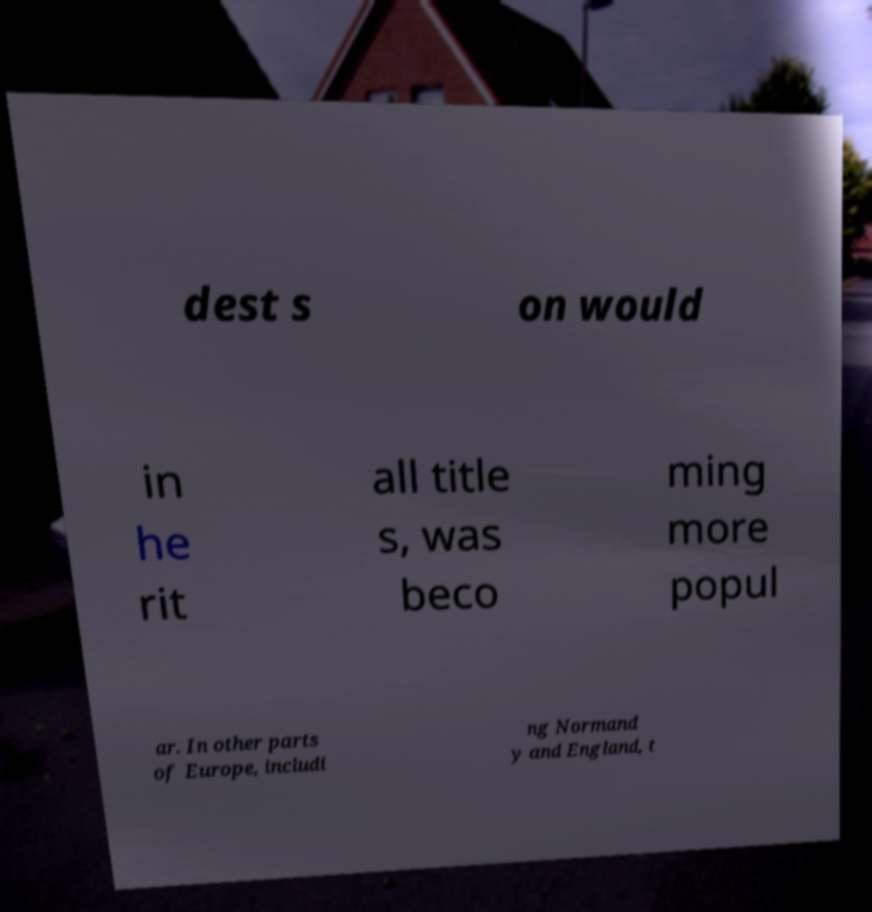Could you extract and type out the text from this image? dest s on would in he rit all title s, was beco ming more popul ar. In other parts of Europe, includi ng Normand y and England, t 